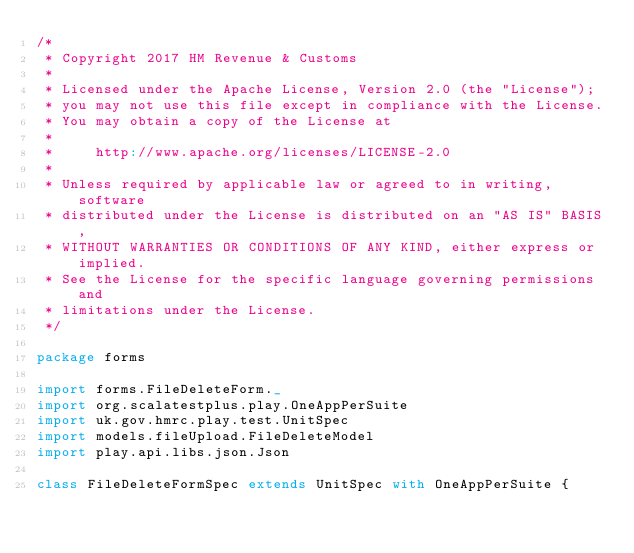Convert code to text. <code><loc_0><loc_0><loc_500><loc_500><_Scala_>/*
 * Copyright 2017 HM Revenue & Customs
 *
 * Licensed under the Apache License, Version 2.0 (the "License");
 * you may not use this file except in compliance with the License.
 * You may obtain a copy of the License at
 *
 *     http://www.apache.org/licenses/LICENSE-2.0
 *
 * Unless required by applicable law or agreed to in writing, software
 * distributed under the License is distributed on an "AS IS" BASIS,
 * WITHOUT WARRANTIES OR CONDITIONS OF ANY KIND, either express or implied.
 * See the License for the specific language governing permissions and
 * limitations under the License.
 */

package forms

import forms.FileDeleteForm._
import org.scalatestplus.play.OneAppPerSuite
import uk.gov.hmrc.play.test.UnitSpec
import models.fileUpload.FileDeleteModel
import play.api.libs.json.Json

class FileDeleteFormSpec extends UnitSpec with OneAppPerSuite {
</code> 